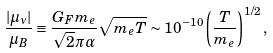<formula> <loc_0><loc_0><loc_500><loc_500>\frac { | \mu _ { \nu } | } { \mu _ { B } } \equiv \frac { G _ { F } m _ { e } } { \sqrt { 2 } \pi \alpha } \sqrt { m _ { e } T } \sim 1 0 ^ { - 1 0 } \left ( \frac { T } { m _ { e } } \right ) ^ { 1 / 2 } ,</formula> 